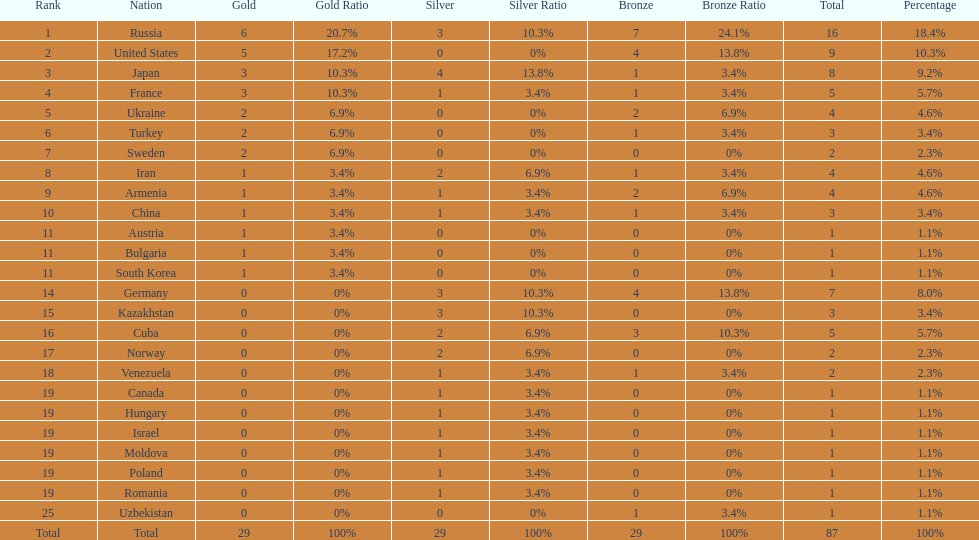How many combined gold medals did japan and france win? 6. 